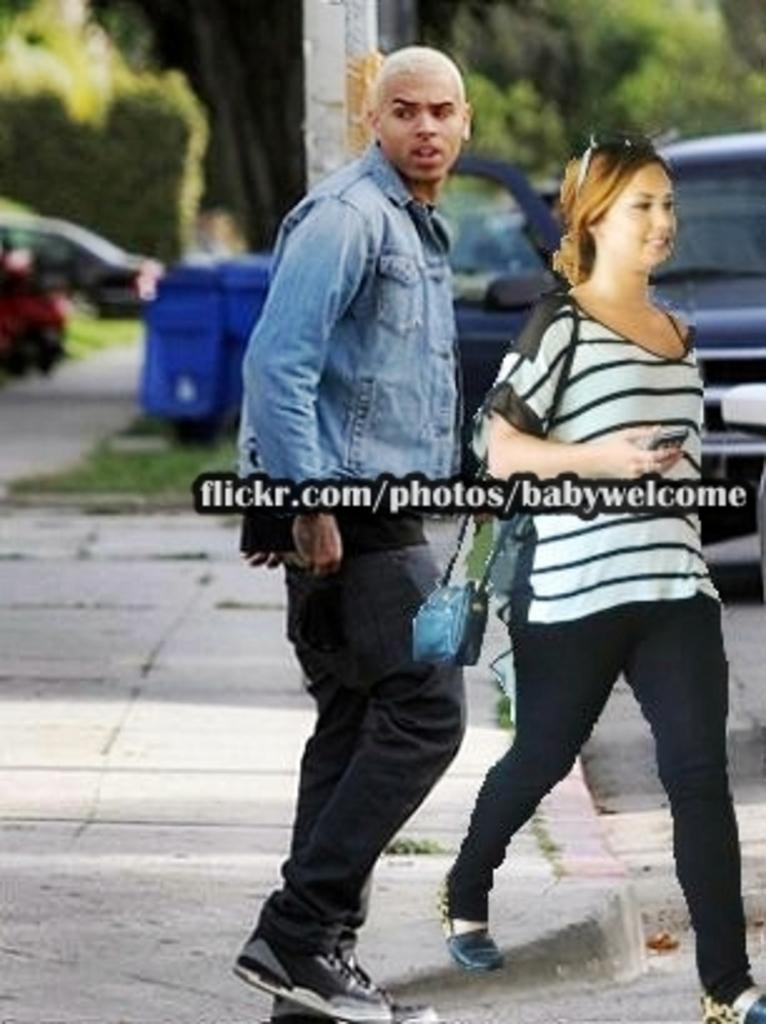<image>
Relay a brief, clear account of the picture shown. The image of a man and woman was presented by flickr.com. 